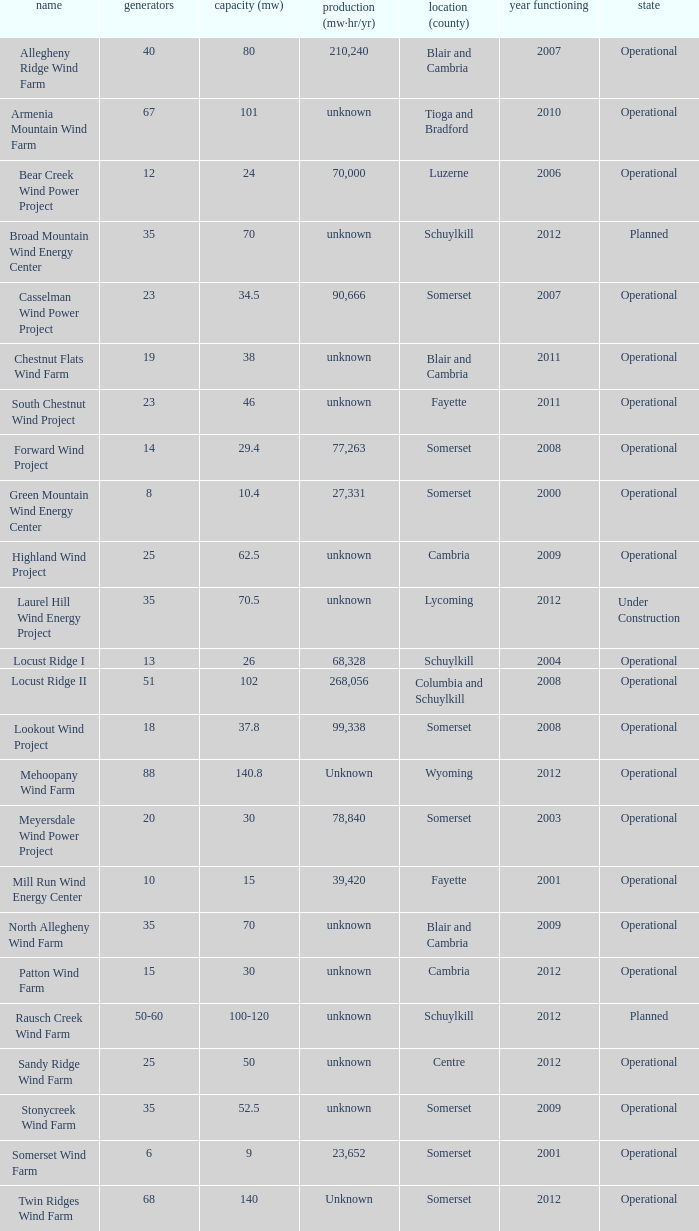What year was Fayette operational at 46? 2011.0. 